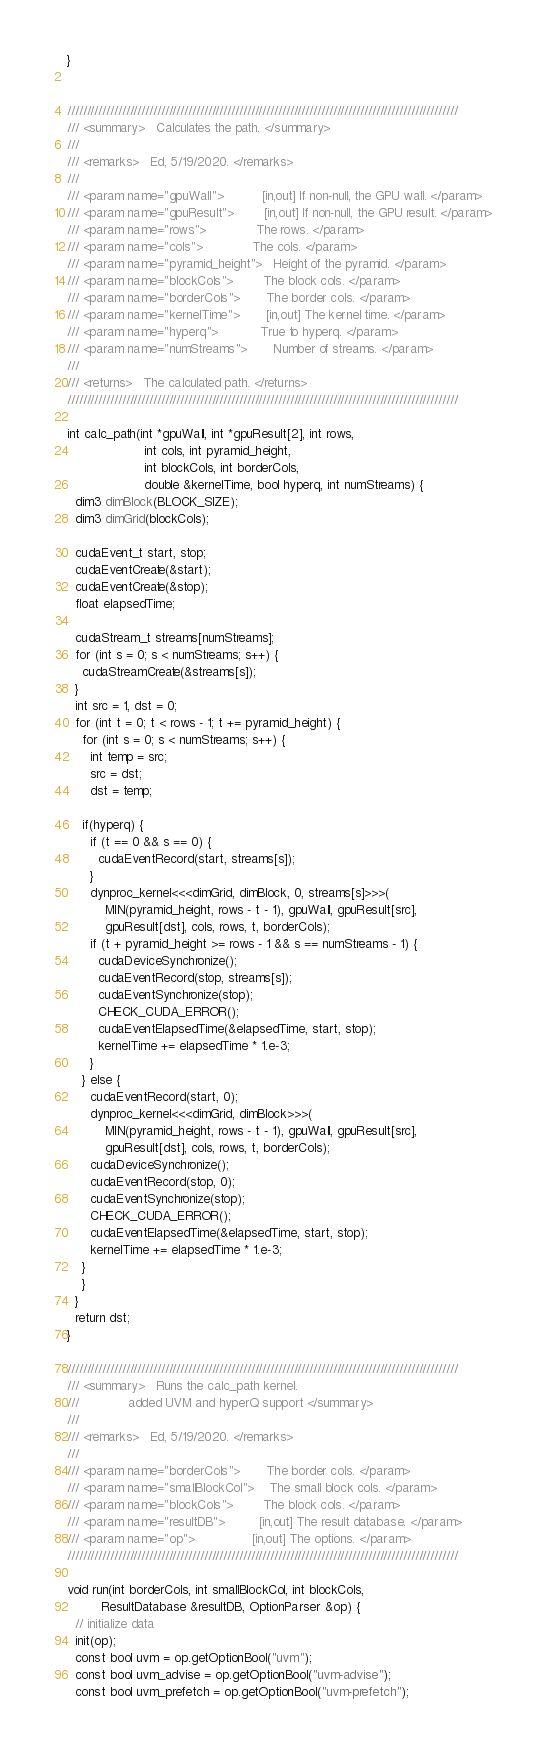<code> <loc_0><loc_0><loc_500><loc_500><_Cuda_>}


////////////////////////////////////////////////////////////////////////////////////////////////////
/// <summary>	Calculates the path. </summary>
///
/// <remarks>	Ed, 5/19/2020. </remarks>
///
/// <param name="gpuWall">		 	[in,out] If non-null, the GPU wall. </param>
/// <param name="gpuResult">	 	[in,out] If non-null, the GPU result. </param>
/// <param name="rows">			 	The rows. </param>
/// <param name="cols">			 	The cols. </param>
/// <param name="pyramid_height">	Height of the pyramid. </param>
/// <param name="blockCols">	 	The block cols. </param>
/// <param name="borderCols">	 	The border cols. </param>
/// <param name="kernelTime">	 	[in,out] The kernel time. </param>
/// <param name="hyperq">		 	True to hyperq. </param>
/// <param name="numStreams">	 	Number of streams. </param>
///
/// <returns>	The calculated path. </returns>
////////////////////////////////////////////////////////////////////////////////////////////////////

int calc_path(int *gpuWall, int *gpuResult[2], int rows,
                    int cols, int pyramid_height,
                    int blockCols, int borderCols,
                    double &kernelTime, bool hyperq, int numStreams) {
  dim3 dimBlock(BLOCK_SIZE);
  dim3 dimGrid(blockCols);

  cudaEvent_t start, stop;
  cudaEventCreate(&start);
  cudaEventCreate(&stop);
  float elapsedTime;

  cudaStream_t streams[numStreams];
  for (int s = 0; s < numStreams; s++) {
    cudaStreamCreate(&streams[s]);
  }
  int src = 1, dst = 0;
  for (int t = 0; t < rows - 1; t += pyramid_height) {
    for (int s = 0; s < numStreams; s++) {
      int temp = src;
      src = dst;
      dst = temp;

    if(hyperq) {
      if (t == 0 && s == 0) {
        cudaEventRecord(start, streams[s]);
      }
      dynproc_kernel<<<dimGrid, dimBlock, 0, streams[s]>>>(
          MIN(pyramid_height, rows - t - 1), gpuWall, gpuResult[src],
          gpuResult[dst], cols, rows, t, borderCols);
      if (t + pyramid_height >= rows - 1 && s == numStreams - 1) {
        cudaDeviceSynchronize();
        cudaEventRecord(stop, streams[s]);
        cudaEventSynchronize(stop);
        CHECK_CUDA_ERROR();
        cudaEventElapsedTime(&elapsedTime, start, stop);
        kernelTime += elapsedTime * 1.e-3;
      }
    } else {
      cudaEventRecord(start, 0);
      dynproc_kernel<<<dimGrid, dimBlock>>>(
          MIN(pyramid_height, rows - t - 1), gpuWall, gpuResult[src],
          gpuResult[dst], cols, rows, t, borderCols);
      cudaDeviceSynchronize();
      cudaEventRecord(stop, 0);
      cudaEventSynchronize(stop);
      CHECK_CUDA_ERROR();
      cudaEventElapsedTime(&elapsedTime, start, stop);
      kernelTime += elapsedTime * 1.e-3;
    }
    }
  }
  return dst;
}

////////////////////////////////////////////////////////////////////////////////////////////////////
/// <summary>	Runs the calc_path kernel.
/// 			added UVM and hyperQ support </summary>
///
/// <remarks>	Ed, 5/19/2020. </remarks>
///
/// <param name="borderCols">   	The border cols. </param>
/// <param name="smallBlockCol">	The small block cols. </param>
/// <param name="blockCols">		The block cols. </param>
/// <param name="resultDB">			[in,out] The result database. </param>
/// <param name="op">				[in,out] The options. </param>
////////////////////////////////////////////////////////////////////////////////////////////////////

void run(int borderCols, int smallBlockCol, int blockCols,
         ResultDatabase &resultDB, OptionParser &op) {
  // initialize data
  init(op);
  const bool uvm = op.getOptionBool("uvm");
  const bool uvm_advise = op.getOptionBool("uvm-advise");
  const bool uvm_prefetch = op.getOptionBool("uvm-prefetch");</code> 